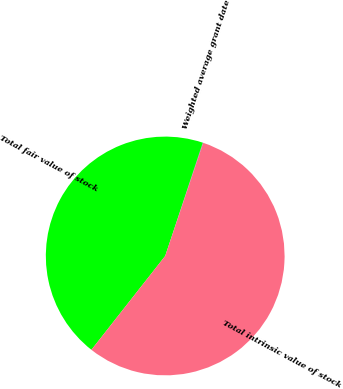Convert chart to OTSL. <chart><loc_0><loc_0><loc_500><loc_500><pie_chart><fcel>Weighted average grant date<fcel>Total fair value of stock<fcel>Total intrinsic value of stock<nl><fcel>0.06%<fcel>44.5%<fcel>55.45%<nl></chart> 